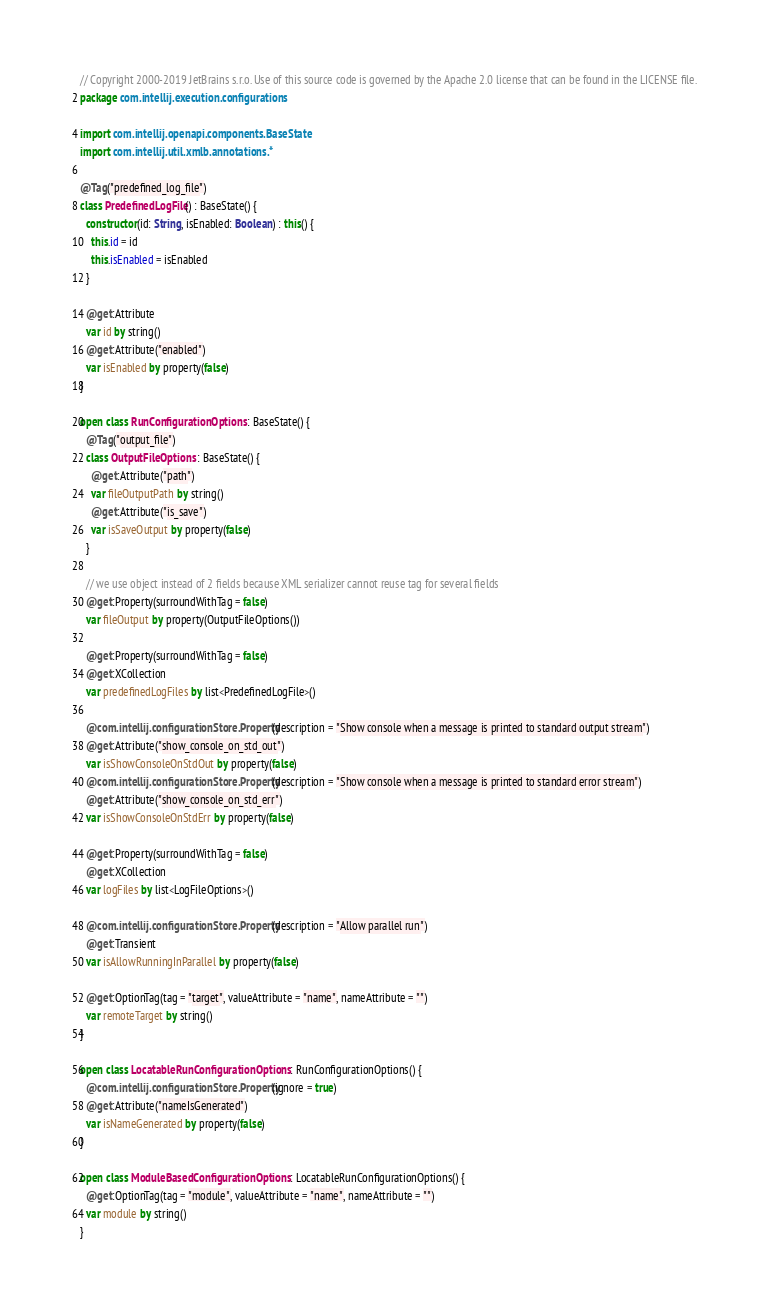<code> <loc_0><loc_0><loc_500><loc_500><_Kotlin_>// Copyright 2000-2019 JetBrains s.r.o. Use of this source code is governed by the Apache 2.0 license that can be found in the LICENSE file.
package com.intellij.execution.configurations

import com.intellij.openapi.components.BaseState
import com.intellij.util.xmlb.annotations.*

@Tag("predefined_log_file")
class PredefinedLogFile() : BaseState() {
  constructor(id: String, isEnabled: Boolean) : this() {
    this.id = id
    this.isEnabled = isEnabled
  }

  @get:Attribute
  var id by string()
  @get:Attribute("enabled")
  var isEnabled by property(false)
}

open class RunConfigurationOptions : BaseState() {
  @Tag("output_file")
  class OutputFileOptions : BaseState() {
    @get:Attribute("path")
    var fileOutputPath by string()
    @get:Attribute("is_save")
    var isSaveOutput by property(false)
  }

  // we use object instead of 2 fields because XML serializer cannot reuse tag for several fields
  @get:Property(surroundWithTag = false)
  var fileOutput by property(OutputFileOptions())

  @get:Property(surroundWithTag = false)
  @get:XCollection
  var predefinedLogFiles by list<PredefinedLogFile>()

  @com.intellij.configurationStore.Property(description = "Show console when a message is printed to standard output stream")
  @get:Attribute("show_console_on_std_out")
  var isShowConsoleOnStdOut by property(false)
  @com.intellij.configurationStore.Property(description = "Show console when a message is printed to standard error stream")
  @get:Attribute("show_console_on_std_err")
  var isShowConsoleOnStdErr by property(false)

  @get:Property(surroundWithTag = false)
  @get:XCollection
  var logFiles by list<LogFileOptions>()

  @com.intellij.configurationStore.Property(description = "Allow parallel run")
  @get:Transient
  var isAllowRunningInParallel by property(false)

  @get:OptionTag(tag = "target", valueAttribute = "name", nameAttribute = "")
  var remoteTarget by string()
}

open class LocatableRunConfigurationOptions : RunConfigurationOptions() {
  @com.intellij.configurationStore.Property(ignore = true)
  @get:Attribute("nameIsGenerated")
  var isNameGenerated by property(false)
}

open class ModuleBasedConfigurationOptions : LocatableRunConfigurationOptions() {
  @get:OptionTag(tag = "module", valueAttribute = "name", nameAttribute = "")
  var module by string()
}</code> 